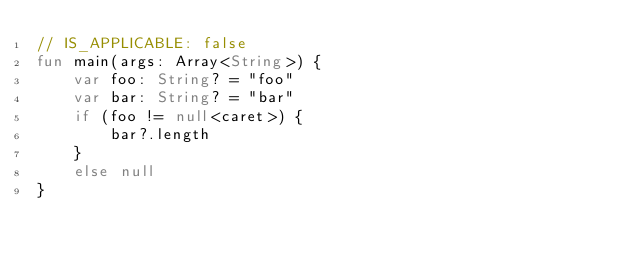<code> <loc_0><loc_0><loc_500><loc_500><_Kotlin_>// IS_APPLICABLE: false
fun main(args: Array<String>) {
    var foo: String? = "foo"
    var bar: String? = "bar"
    if (foo != null<caret>) {
        bar?.length
    }
    else null
}
</code> 